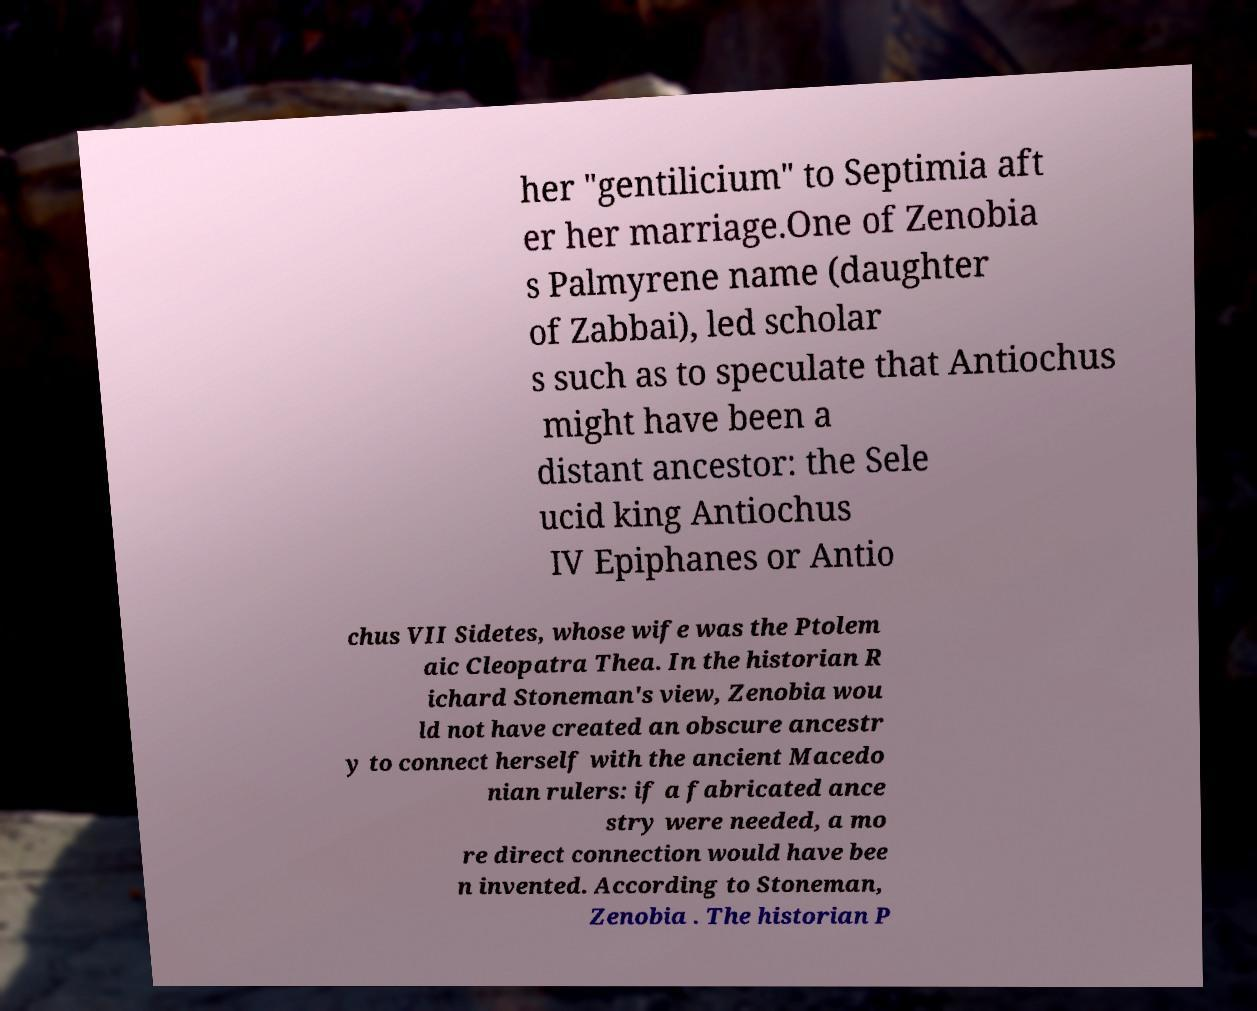I need the written content from this picture converted into text. Can you do that? her "gentilicium" to Septimia aft er her marriage.One of Zenobia s Palmyrene name (daughter of Zabbai), led scholar s such as to speculate that Antiochus might have been a distant ancestor: the Sele ucid king Antiochus IV Epiphanes or Antio chus VII Sidetes, whose wife was the Ptolem aic Cleopatra Thea. In the historian R ichard Stoneman's view, Zenobia wou ld not have created an obscure ancestr y to connect herself with the ancient Macedo nian rulers: if a fabricated ance stry were needed, a mo re direct connection would have bee n invented. According to Stoneman, Zenobia . The historian P 